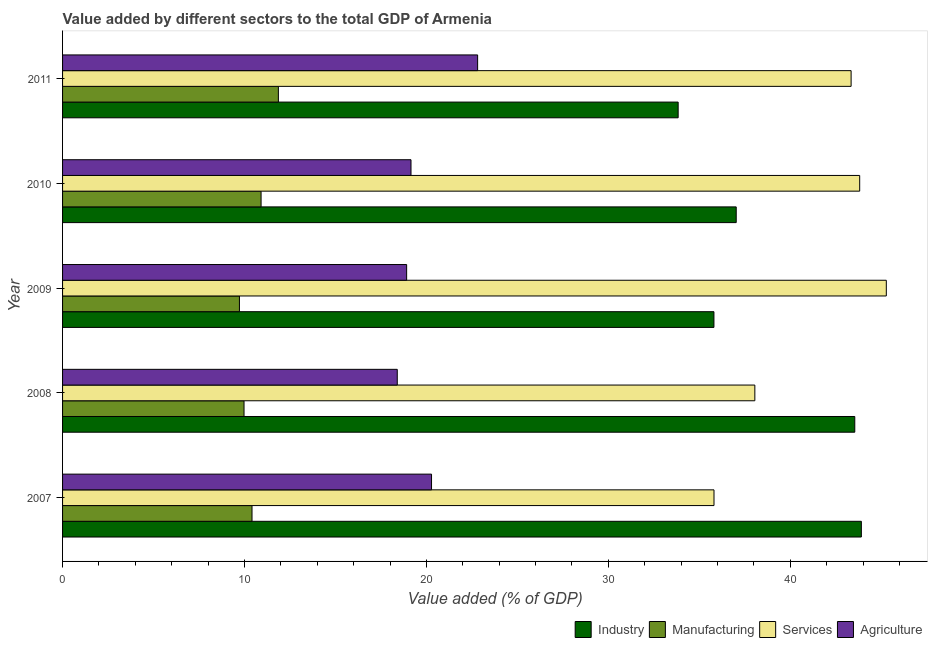How many different coloured bars are there?
Provide a succinct answer. 4. How many groups of bars are there?
Your response must be concise. 5. Are the number of bars per tick equal to the number of legend labels?
Your answer should be compact. Yes. What is the label of the 3rd group of bars from the top?
Your response must be concise. 2009. In how many cases, is the number of bars for a given year not equal to the number of legend labels?
Your answer should be very brief. 0. What is the value added by services sector in 2008?
Provide a succinct answer. 38.05. Across all years, what is the maximum value added by agricultural sector?
Ensure brevity in your answer.  22.82. Across all years, what is the minimum value added by agricultural sector?
Your answer should be compact. 18.4. In which year was the value added by manufacturing sector maximum?
Provide a succinct answer. 2011. In which year was the value added by industrial sector minimum?
Keep it short and to the point. 2011. What is the total value added by services sector in the graph?
Your response must be concise. 206.31. What is the difference between the value added by services sector in 2008 and that in 2010?
Keep it short and to the point. -5.76. What is the difference between the value added by agricultural sector in 2010 and the value added by services sector in 2008?
Your answer should be very brief. -18.9. What is the average value added by manufacturing sector per year?
Provide a short and direct response. 10.58. In the year 2011, what is the difference between the value added by agricultural sector and value added by industrial sector?
Your response must be concise. -11.02. In how many years, is the value added by agricultural sector greater than 42 %?
Offer a very short reply. 0. What is the ratio of the value added by agricultural sector in 2008 to that in 2011?
Give a very brief answer. 0.81. What is the difference between the highest and the lowest value added by services sector?
Offer a terse response. 9.47. In how many years, is the value added by manufacturing sector greater than the average value added by manufacturing sector taken over all years?
Keep it short and to the point. 2. Is the sum of the value added by services sector in 2010 and 2011 greater than the maximum value added by industrial sector across all years?
Keep it short and to the point. Yes. Is it the case that in every year, the sum of the value added by industrial sector and value added by manufacturing sector is greater than the sum of value added by services sector and value added by agricultural sector?
Your answer should be compact. No. What does the 2nd bar from the top in 2010 represents?
Ensure brevity in your answer.  Services. What does the 1st bar from the bottom in 2008 represents?
Your answer should be very brief. Industry. How many bars are there?
Your answer should be compact. 20. Are all the bars in the graph horizontal?
Your response must be concise. Yes. How many years are there in the graph?
Offer a terse response. 5. Are the values on the major ticks of X-axis written in scientific E-notation?
Provide a succinct answer. No. Does the graph contain any zero values?
Offer a terse response. No. What is the title of the graph?
Ensure brevity in your answer.  Value added by different sectors to the total GDP of Armenia. Does "Austria" appear as one of the legend labels in the graph?
Give a very brief answer. No. What is the label or title of the X-axis?
Give a very brief answer. Value added (% of GDP). What is the label or title of the Y-axis?
Your answer should be compact. Year. What is the Value added (% of GDP) of Industry in 2007?
Ensure brevity in your answer.  43.91. What is the Value added (% of GDP) of Manufacturing in 2007?
Your answer should be very brief. 10.41. What is the Value added (% of GDP) of Services in 2007?
Ensure brevity in your answer.  35.81. What is the Value added (% of GDP) in Agriculture in 2007?
Keep it short and to the point. 20.28. What is the Value added (% of GDP) in Industry in 2008?
Your answer should be very brief. 43.55. What is the Value added (% of GDP) of Manufacturing in 2008?
Ensure brevity in your answer.  9.98. What is the Value added (% of GDP) of Services in 2008?
Ensure brevity in your answer.  38.05. What is the Value added (% of GDP) in Agriculture in 2008?
Ensure brevity in your answer.  18.4. What is the Value added (% of GDP) of Industry in 2009?
Provide a short and direct response. 35.81. What is the Value added (% of GDP) of Manufacturing in 2009?
Your answer should be compact. 9.72. What is the Value added (% of GDP) in Services in 2009?
Provide a succinct answer. 45.28. What is the Value added (% of GDP) of Agriculture in 2009?
Your answer should be compact. 18.91. What is the Value added (% of GDP) of Industry in 2010?
Your answer should be very brief. 37.03. What is the Value added (% of GDP) in Manufacturing in 2010?
Your answer should be compact. 10.91. What is the Value added (% of GDP) of Services in 2010?
Offer a terse response. 43.82. What is the Value added (% of GDP) of Agriculture in 2010?
Give a very brief answer. 19.15. What is the Value added (% of GDP) in Industry in 2011?
Provide a short and direct response. 33.84. What is the Value added (% of GDP) of Manufacturing in 2011?
Offer a terse response. 11.86. What is the Value added (% of GDP) of Services in 2011?
Your answer should be very brief. 43.35. What is the Value added (% of GDP) in Agriculture in 2011?
Provide a short and direct response. 22.82. Across all years, what is the maximum Value added (% of GDP) in Industry?
Your answer should be compact. 43.91. Across all years, what is the maximum Value added (% of GDP) in Manufacturing?
Ensure brevity in your answer.  11.86. Across all years, what is the maximum Value added (% of GDP) of Services?
Your response must be concise. 45.28. Across all years, what is the maximum Value added (% of GDP) in Agriculture?
Your response must be concise. 22.82. Across all years, what is the minimum Value added (% of GDP) in Industry?
Make the answer very short. 33.84. Across all years, what is the minimum Value added (% of GDP) of Manufacturing?
Offer a terse response. 9.72. Across all years, what is the minimum Value added (% of GDP) of Services?
Your answer should be compact. 35.81. Across all years, what is the minimum Value added (% of GDP) in Agriculture?
Your answer should be compact. 18.4. What is the total Value added (% of GDP) of Industry in the graph?
Provide a succinct answer. 194.13. What is the total Value added (% of GDP) in Manufacturing in the graph?
Provide a short and direct response. 52.89. What is the total Value added (% of GDP) in Services in the graph?
Your answer should be very brief. 206.31. What is the total Value added (% of GDP) of Agriculture in the graph?
Your answer should be compact. 99.56. What is the difference between the Value added (% of GDP) in Industry in 2007 and that in 2008?
Your answer should be very brief. 0.36. What is the difference between the Value added (% of GDP) in Manufacturing in 2007 and that in 2008?
Give a very brief answer. 0.44. What is the difference between the Value added (% of GDP) in Services in 2007 and that in 2008?
Give a very brief answer. -2.25. What is the difference between the Value added (% of GDP) of Agriculture in 2007 and that in 2008?
Keep it short and to the point. 1.88. What is the difference between the Value added (% of GDP) of Industry in 2007 and that in 2009?
Offer a terse response. 8.1. What is the difference between the Value added (% of GDP) in Manufacturing in 2007 and that in 2009?
Make the answer very short. 0.69. What is the difference between the Value added (% of GDP) in Services in 2007 and that in 2009?
Your answer should be compact. -9.47. What is the difference between the Value added (% of GDP) of Agriculture in 2007 and that in 2009?
Keep it short and to the point. 1.37. What is the difference between the Value added (% of GDP) in Industry in 2007 and that in 2010?
Provide a succinct answer. 6.88. What is the difference between the Value added (% of GDP) of Manufacturing in 2007 and that in 2010?
Offer a very short reply. -0.5. What is the difference between the Value added (% of GDP) of Services in 2007 and that in 2010?
Give a very brief answer. -8.01. What is the difference between the Value added (% of GDP) of Agriculture in 2007 and that in 2010?
Make the answer very short. 1.13. What is the difference between the Value added (% of GDP) of Industry in 2007 and that in 2011?
Give a very brief answer. 10.07. What is the difference between the Value added (% of GDP) in Manufacturing in 2007 and that in 2011?
Ensure brevity in your answer.  -1.45. What is the difference between the Value added (% of GDP) of Services in 2007 and that in 2011?
Keep it short and to the point. -7.54. What is the difference between the Value added (% of GDP) in Agriculture in 2007 and that in 2011?
Keep it short and to the point. -2.53. What is the difference between the Value added (% of GDP) of Industry in 2008 and that in 2009?
Provide a succinct answer. 7.74. What is the difference between the Value added (% of GDP) in Manufacturing in 2008 and that in 2009?
Your response must be concise. 0.25. What is the difference between the Value added (% of GDP) of Services in 2008 and that in 2009?
Your answer should be very brief. -7.23. What is the difference between the Value added (% of GDP) of Agriculture in 2008 and that in 2009?
Keep it short and to the point. -0.52. What is the difference between the Value added (% of GDP) of Industry in 2008 and that in 2010?
Offer a very short reply. 6.52. What is the difference between the Value added (% of GDP) of Manufacturing in 2008 and that in 2010?
Ensure brevity in your answer.  -0.94. What is the difference between the Value added (% of GDP) in Services in 2008 and that in 2010?
Give a very brief answer. -5.76. What is the difference between the Value added (% of GDP) in Agriculture in 2008 and that in 2010?
Offer a very short reply. -0.75. What is the difference between the Value added (% of GDP) in Industry in 2008 and that in 2011?
Keep it short and to the point. 9.71. What is the difference between the Value added (% of GDP) of Manufacturing in 2008 and that in 2011?
Give a very brief answer. -1.89. What is the difference between the Value added (% of GDP) of Services in 2008 and that in 2011?
Provide a succinct answer. -5.29. What is the difference between the Value added (% of GDP) in Agriculture in 2008 and that in 2011?
Offer a very short reply. -4.42. What is the difference between the Value added (% of GDP) in Industry in 2009 and that in 2010?
Give a very brief answer. -1.22. What is the difference between the Value added (% of GDP) of Manufacturing in 2009 and that in 2010?
Your response must be concise. -1.19. What is the difference between the Value added (% of GDP) of Services in 2009 and that in 2010?
Your response must be concise. 1.46. What is the difference between the Value added (% of GDP) in Agriculture in 2009 and that in 2010?
Keep it short and to the point. -0.24. What is the difference between the Value added (% of GDP) of Industry in 2009 and that in 2011?
Make the answer very short. 1.97. What is the difference between the Value added (% of GDP) in Manufacturing in 2009 and that in 2011?
Your response must be concise. -2.14. What is the difference between the Value added (% of GDP) in Services in 2009 and that in 2011?
Provide a succinct answer. 1.93. What is the difference between the Value added (% of GDP) in Agriculture in 2009 and that in 2011?
Ensure brevity in your answer.  -3.9. What is the difference between the Value added (% of GDP) of Industry in 2010 and that in 2011?
Your answer should be compact. 3.19. What is the difference between the Value added (% of GDP) in Manufacturing in 2010 and that in 2011?
Keep it short and to the point. -0.95. What is the difference between the Value added (% of GDP) of Services in 2010 and that in 2011?
Ensure brevity in your answer.  0.47. What is the difference between the Value added (% of GDP) in Agriculture in 2010 and that in 2011?
Give a very brief answer. -3.66. What is the difference between the Value added (% of GDP) in Industry in 2007 and the Value added (% of GDP) in Manufacturing in 2008?
Keep it short and to the point. 33.93. What is the difference between the Value added (% of GDP) in Industry in 2007 and the Value added (% of GDP) in Services in 2008?
Give a very brief answer. 5.85. What is the difference between the Value added (% of GDP) of Industry in 2007 and the Value added (% of GDP) of Agriculture in 2008?
Provide a succinct answer. 25.51. What is the difference between the Value added (% of GDP) in Manufacturing in 2007 and the Value added (% of GDP) in Services in 2008?
Make the answer very short. -27.64. What is the difference between the Value added (% of GDP) of Manufacturing in 2007 and the Value added (% of GDP) of Agriculture in 2008?
Your answer should be compact. -7.98. What is the difference between the Value added (% of GDP) in Services in 2007 and the Value added (% of GDP) in Agriculture in 2008?
Your answer should be very brief. 17.41. What is the difference between the Value added (% of GDP) of Industry in 2007 and the Value added (% of GDP) of Manufacturing in 2009?
Offer a terse response. 34.19. What is the difference between the Value added (% of GDP) of Industry in 2007 and the Value added (% of GDP) of Services in 2009?
Give a very brief answer. -1.37. What is the difference between the Value added (% of GDP) of Industry in 2007 and the Value added (% of GDP) of Agriculture in 2009?
Your response must be concise. 24.99. What is the difference between the Value added (% of GDP) in Manufacturing in 2007 and the Value added (% of GDP) in Services in 2009?
Your answer should be very brief. -34.87. What is the difference between the Value added (% of GDP) of Manufacturing in 2007 and the Value added (% of GDP) of Agriculture in 2009?
Offer a terse response. -8.5. What is the difference between the Value added (% of GDP) of Services in 2007 and the Value added (% of GDP) of Agriculture in 2009?
Give a very brief answer. 16.9. What is the difference between the Value added (% of GDP) of Industry in 2007 and the Value added (% of GDP) of Manufacturing in 2010?
Provide a short and direct response. 33. What is the difference between the Value added (% of GDP) in Industry in 2007 and the Value added (% of GDP) in Services in 2010?
Provide a succinct answer. 0.09. What is the difference between the Value added (% of GDP) in Industry in 2007 and the Value added (% of GDP) in Agriculture in 2010?
Your answer should be compact. 24.76. What is the difference between the Value added (% of GDP) in Manufacturing in 2007 and the Value added (% of GDP) in Services in 2010?
Provide a succinct answer. -33.4. What is the difference between the Value added (% of GDP) in Manufacturing in 2007 and the Value added (% of GDP) in Agriculture in 2010?
Your answer should be compact. -8.74. What is the difference between the Value added (% of GDP) in Services in 2007 and the Value added (% of GDP) in Agriculture in 2010?
Offer a very short reply. 16.66. What is the difference between the Value added (% of GDP) in Industry in 2007 and the Value added (% of GDP) in Manufacturing in 2011?
Provide a short and direct response. 32.05. What is the difference between the Value added (% of GDP) of Industry in 2007 and the Value added (% of GDP) of Services in 2011?
Offer a terse response. 0.56. What is the difference between the Value added (% of GDP) of Industry in 2007 and the Value added (% of GDP) of Agriculture in 2011?
Your response must be concise. 21.09. What is the difference between the Value added (% of GDP) of Manufacturing in 2007 and the Value added (% of GDP) of Services in 2011?
Your response must be concise. -32.93. What is the difference between the Value added (% of GDP) in Manufacturing in 2007 and the Value added (% of GDP) in Agriculture in 2011?
Make the answer very short. -12.4. What is the difference between the Value added (% of GDP) in Services in 2007 and the Value added (% of GDP) in Agriculture in 2011?
Make the answer very short. 12.99. What is the difference between the Value added (% of GDP) in Industry in 2008 and the Value added (% of GDP) in Manufacturing in 2009?
Your answer should be compact. 33.83. What is the difference between the Value added (% of GDP) of Industry in 2008 and the Value added (% of GDP) of Services in 2009?
Make the answer very short. -1.73. What is the difference between the Value added (% of GDP) of Industry in 2008 and the Value added (% of GDP) of Agriculture in 2009?
Make the answer very short. 24.63. What is the difference between the Value added (% of GDP) in Manufacturing in 2008 and the Value added (% of GDP) in Services in 2009?
Your answer should be very brief. -35.31. What is the difference between the Value added (% of GDP) of Manufacturing in 2008 and the Value added (% of GDP) of Agriculture in 2009?
Ensure brevity in your answer.  -8.94. What is the difference between the Value added (% of GDP) in Services in 2008 and the Value added (% of GDP) in Agriculture in 2009?
Make the answer very short. 19.14. What is the difference between the Value added (% of GDP) of Industry in 2008 and the Value added (% of GDP) of Manufacturing in 2010?
Give a very brief answer. 32.64. What is the difference between the Value added (% of GDP) of Industry in 2008 and the Value added (% of GDP) of Services in 2010?
Offer a very short reply. -0.27. What is the difference between the Value added (% of GDP) of Industry in 2008 and the Value added (% of GDP) of Agriculture in 2010?
Give a very brief answer. 24.39. What is the difference between the Value added (% of GDP) of Manufacturing in 2008 and the Value added (% of GDP) of Services in 2010?
Your answer should be very brief. -33.84. What is the difference between the Value added (% of GDP) of Manufacturing in 2008 and the Value added (% of GDP) of Agriculture in 2010?
Ensure brevity in your answer.  -9.18. What is the difference between the Value added (% of GDP) in Services in 2008 and the Value added (% of GDP) in Agriculture in 2010?
Provide a short and direct response. 18.9. What is the difference between the Value added (% of GDP) of Industry in 2008 and the Value added (% of GDP) of Manufacturing in 2011?
Offer a very short reply. 31.68. What is the difference between the Value added (% of GDP) in Industry in 2008 and the Value added (% of GDP) in Services in 2011?
Ensure brevity in your answer.  0.2. What is the difference between the Value added (% of GDP) of Industry in 2008 and the Value added (% of GDP) of Agriculture in 2011?
Provide a succinct answer. 20.73. What is the difference between the Value added (% of GDP) of Manufacturing in 2008 and the Value added (% of GDP) of Services in 2011?
Give a very brief answer. -33.37. What is the difference between the Value added (% of GDP) of Manufacturing in 2008 and the Value added (% of GDP) of Agriculture in 2011?
Offer a terse response. -12.84. What is the difference between the Value added (% of GDP) of Services in 2008 and the Value added (% of GDP) of Agriculture in 2011?
Make the answer very short. 15.24. What is the difference between the Value added (% of GDP) in Industry in 2009 and the Value added (% of GDP) in Manufacturing in 2010?
Your answer should be compact. 24.89. What is the difference between the Value added (% of GDP) of Industry in 2009 and the Value added (% of GDP) of Services in 2010?
Your response must be concise. -8.01. What is the difference between the Value added (% of GDP) in Industry in 2009 and the Value added (% of GDP) in Agriculture in 2010?
Your answer should be compact. 16.65. What is the difference between the Value added (% of GDP) of Manufacturing in 2009 and the Value added (% of GDP) of Services in 2010?
Offer a very short reply. -34.09. What is the difference between the Value added (% of GDP) in Manufacturing in 2009 and the Value added (% of GDP) in Agriculture in 2010?
Make the answer very short. -9.43. What is the difference between the Value added (% of GDP) in Services in 2009 and the Value added (% of GDP) in Agriculture in 2010?
Offer a very short reply. 26.13. What is the difference between the Value added (% of GDP) in Industry in 2009 and the Value added (% of GDP) in Manufacturing in 2011?
Ensure brevity in your answer.  23.94. What is the difference between the Value added (% of GDP) of Industry in 2009 and the Value added (% of GDP) of Services in 2011?
Provide a succinct answer. -7.54. What is the difference between the Value added (% of GDP) of Industry in 2009 and the Value added (% of GDP) of Agriculture in 2011?
Offer a very short reply. 12.99. What is the difference between the Value added (% of GDP) in Manufacturing in 2009 and the Value added (% of GDP) in Services in 2011?
Your answer should be very brief. -33.62. What is the difference between the Value added (% of GDP) in Manufacturing in 2009 and the Value added (% of GDP) in Agriculture in 2011?
Keep it short and to the point. -13.09. What is the difference between the Value added (% of GDP) in Services in 2009 and the Value added (% of GDP) in Agriculture in 2011?
Provide a succinct answer. 22.46. What is the difference between the Value added (% of GDP) of Industry in 2010 and the Value added (% of GDP) of Manufacturing in 2011?
Offer a terse response. 25.17. What is the difference between the Value added (% of GDP) of Industry in 2010 and the Value added (% of GDP) of Services in 2011?
Your answer should be compact. -6.32. What is the difference between the Value added (% of GDP) in Industry in 2010 and the Value added (% of GDP) in Agriculture in 2011?
Make the answer very short. 14.21. What is the difference between the Value added (% of GDP) of Manufacturing in 2010 and the Value added (% of GDP) of Services in 2011?
Ensure brevity in your answer.  -32.43. What is the difference between the Value added (% of GDP) of Manufacturing in 2010 and the Value added (% of GDP) of Agriculture in 2011?
Give a very brief answer. -11.9. What is the difference between the Value added (% of GDP) in Services in 2010 and the Value added (% of GDP) in Agriculture in 2011?
Your response must be concise. 21. What is the average Value added (% of GDP) in Industry per year?
Your answer should be compact. 38.83. What is the average Value added (% of GDP) of Manufacturing per year?
Keep it short and to the point. 10.58. What is the average Value added (% of GDP) of Services per year?
Your response must be concise. 41.26. What is the average Value added (% of GDP) in Agriculture per year?
Offer a terse response. 19.91. In the year 2007, what is the difference between the Value added (% of GDP) in Industry and Value added (% of GDP) in Manufacturing?
Keep it short and to the point. 33.49. In the year 2007, what is the difference between the Value added (% of GDP) of Industry and Value added (% of GDP) of Services?
Your response must be concise. 8.1. In the year 2007, what is the difference between the Value added (% of GDP) of Industry and Value added (% of GDP) of Agriculture?
Your response must be concise. 23.63. In the year 2007, what is the difference between the Value added (% of GDP) of Manufacturing and Value added (% of GDP) of Services?
Offer a terse response. -25.4. In the year 2007, what is the difference between the Value added (% of GDP) of Manufacturing and Value added (% of GDP) of Agriculture?
Provide a succinct answer. -9.87. In the year 2007, what is the difference between the Value added (% of GDP) in Services and Value added (% of GDP) in Agriculture?
Your response must be concise. 15.53. In the year 2008, what is the difference between the Value added (% of GDP) of Industry and Value added (% of GDP) of Manufacturing?
Your answer should be compact. 33.57. In the year 2008, what is the difference between the Value added (% of GDP) in Industry and Value added (% of GDP) in Services?
Make the answer very short. 5.49. In the year 2008, what is the difference between the Value added (% of GDP) of Industry and Value added (% of GDP) of Agriculture?
Give a very brief answer. 25.15. In the year 2008, what is the difference between the Value added (% of GDP) in Manufacturing and Value added (% of GDP) in Services?
Offer a terse response. -28.08. In the year 2008, what is the difference between the Value added (% of GDP) in Manufacturing and Value added (% of GDP) in Agriculture?
Make the answer very short. -8.42. In the year 2008, what is the difference between the Value added (% of GDP) in Services and Value added (% of GDP) in Agriculture?
Keep it short and to the point. 19.66. In the year 2009, what is the difference between the Value added (% of GDP) of Industry and Value added (% of GDP) of Manufacturing?
Your answer should be very brief. 26.08. In the year 2009, what is the difference between the Value added (% of GDP) in Industry and Value added (% of GDP) in Services?
Provide a succinct answer. -9.47. In the year 2009, what is the difference between the Value added (% of GDP) of Industry and Value added (% of GDP) of Agriculture?
Your answer should be compact. 16.89. In the year 2009, what is the difference between the Value added (% of GDP) in Manufacturing and Value added (% of GDP) in Services?
Offer a terse response. -35.56. In the year 2009, what is the difference between the Value added (% of GDP) in Manufacturing and Value added (% of GDP) in Agriculture?
Give a very brief answer. -9.19. In the year 2009, what is the difference between the Value added (% of GDP) of Services and Value added (% of GDP) of Agriculture?
Your answer should be very brief. 26.37. In the year 2010, what is the difference between the Value added (% of GDP) of Industry and Value added (% of GDP) of Manufacturing?
Offer a very short reply. 26.12. In the year 2010, what is the difference between the Value added (% of GDP) in Industry and Value added (% of GDP) in Services?
Your response must be concise. -6.79. In the year 2010, what is the difference between the Value added (% of GDP) of Industry and Value added (% of GDP) of Agriculture?
Your response must be concise. 17.88. In the year 2010, what is the difference between the Value added (% of GDP) of Manufacturing and Value added (% of GDP) of Services?
Offer a very short reply. -32.91. In the year 2010, what is the difference between the Value added (% of GDP) of Manufacturing and Value added (% of GDP) of Agriculture?
Keep it short and to the point. -8.24. In the year 2010, what is the difference between the Value added (% of GDP) of Services and Value added (% of GDP) of Agriculture?
Give a very brief answer. 24.66. In the year 2011, what is the difference between the Value added (% of GDP) of Industry and Value added (% of GDP) of Manufacturing?
Give a very brief answer. 21.98. In the year 2011, what is the difference between the Value added (% of GDP) of Industry and Value added (% of GDP) of Services?
Offer a terse response. -9.51. In the year 2011, what is the difference between the Value added (% of GDP) of Industry and Value added (% of GDP) of Agriculture?
Your answer should be compact. 11.02. In the year 2011, what is the difference between the Value added (% of GDP) in Manufacturing and Value added (% of GDP) in Services?
Ensure brevity in your answer.  -31.48. In the year 2011, what is the difference between the Value added (% of GDP) in Manufacturing and Value added (% of GDP) in Agriculture?
Keep it short and to the point. -10.95. In the year 2011, what is the difference between the Value added (% of GDP) in Services and Value added (% of GDP) in Agriculture?
Your response must be concise. 20.53. What is the ratio of the Value added (% of GDP) of Industry in 2007 to that in 2008?
Give a very brief answer. 1.01. What is the ratio of the Value added (% of GDP) of Manufacturing in 2007 to that in 2008?
Provide a succinct answer. 1.04. What is the ratio of the Value added (% of GDP) of Services in 2007 to that in 2008?
Your answer should be very brief. 0.94. What is the ratio of the Value added (% of GDP) of Agriculture in 2007 to that in 2008?
Your answer should be very brief. 1.1. What is the ratio of the Value added (% of GDP) in Industry in 2007 to that in 2009?
Ensure brevity in your answer.  1.23. What is the ratio of the Value added (% of GDP) in Manufacturing in 2007 to that in 2009?
Ensure brevity in your answer.  1.07. What is the ratio of the Value added (% of GDP) in Services in 2007 to that in 2009?
Your response must be concise. 0.79. What is the ratio of the Value added (% of GDP) of Agriculture in 2007 to that in 2009?
Give a very brief answer. 1.07. What is the ratio of the Value added (% of GDP) in Industry in 2007 to that in 2010?
Provide a succinct answer. 1.19. What is the ratio of the Value added (% of GDP) of Manufacturing in 2007 to that in 2010?
Ensure brevity in your answer.  0.95. What is the ratio of the Value added (% of GDP) of Services in 2007 to that in 2010?
Provide a succinct answer. 0.82. What is the ratio of the Value added (% of GDP) in Agriculture in 2007 to that in 2010?
Your answer should be very brief. 1.06. What is the ratio of the Value added (% of GDP) of Industry in 2007 to that in 2011?
Ensure brevity in your answer.  1.3. What is the ratio of the Value added (% of GDP) of Manufacturing in 2007 to that in 2011?
Give a very brief answer. 0.88. What is the ratio of the Value added (% of GDP) of Services in 2007 to that in 2011?
Ensure brevity in your answer.  0.83. What is the ratio of the Value added (% of GDP) of Agriculture in 2007 to that in 2011?
Your answer should be compact. 0.89. What is the ratio of the Value added (% of GDP) of Industry in 2008 to that in 2009?
Provide a short and direct response. 1.22. What is the ratio of the Value added (% of GDP) in Manufacturing in 2008 to that in 2009?
Ensure brevity in your answer.  1.03. What is the ratio of the Value added (% of GDP) in Services in 2008 to that in 2009?
Provide a succinct answer. 0.84. What is the ratio of the Value added (% of GDP) in Agriculture in 2008 to that in 2009?
Provide a succinct answer. 0.97. What is the ratio of the Value added (% of GDP) in Industry in 2008 to that in 2010?
Provide a short and direct response. 1.18. What is the ratio of the Value added (% of GDP) of Manufacturing in 2008 to that in 2010?
Provide a short and direct response. 0.91. What is the ratio of the Value added (% of GDP) in Services in 2008 to that in 2010?
Offer a terse response. 0.87. What is the ratio of the Value added (% of GDP) of Agriculture in 2008 to that in 2010?
Your response must be concise. 0.96. What is the ratio of the Value added (% of GDP) in Industry in 2008 to that in 2011?
Offer a very short reply. 1.29. What is the ratio of the Value added (% of GDP) in Manufacturing in 2008 to that in 2011?
Your answer should be compact. 0.84. What is the ratio of the Value added (% of GDP) of Services in 2008 to that in 2011?
Your response must be concise. 0.88. What is the ratio of the Value added (% of GDP) in Agriculture in 2008 to that in 2011?
Make the answer very short. 0.81. What is the ratio of the Value added (% of GDP) of Industry in 2009 to that in 2010?
Provide a succinct answer. 0.97. What is the ratio of the Value added (% of GDP) of Manufacturing in 2009 to that in 2010?
Keep it short and to the point. 0.89. What is the ratio of the Value added (% of GDP) in Services in 2009 to that in 2010?
Provide a succinct answer. 1.03. What is the ratio of the Value added (% of GDP) in Agriculture in 2009 to that in 2010?
Make the answer very short. 0.99. What is the ratio of the Value added (% of GDP) in Industry in 2009 to that in 2011?
Give a very brief answer. 1.06. What is the ratio of the Value added (% of GDP) in Manufacturing in 2009 to that in 2011?
Your answer should be compact. 0.82. What is the ratio of the Value added (% of GDP) of Services in 2009 to that in 2011?
Give a very brief answer. 1.04. What is the ratio of the Value added (% of GDP) of Agriculture in 2009 to that in 2011?
Make the answer very short. 0.83. What is the ratio of the Value added (% of GDP) in Industry in 2010 to that in 2011?
Provide a succinct answer. 1.09. What is the ratio of the Value added (% of GDP) in Manufacturing in 2010 to that in 2011?
Keep it short and to the point. 0.92. What is the ratio of the Value added (% of GDP) of Services in 2010 to that in 2011?
Your answer should be very brief. 1.01. What is the ratio of the Value added (% of GDP) in Agriculture in 2010 to that in 2011?
Ensure brevity in your answer.  0.84. What is the difference between the highest and the second highest Value added (% of GDP) in Industry?
Make the answer very short. 0.36. What is the difference between the highest and the second highest Value added (% of GDP) of Manufacturing?
Ensure brevity in your answer.  0.95. What is the difference between the highest and the second highest Value added (% of GDP) of Services?
Your answer should be compact. 1.46. What is the difference between the highest and the second highest Value added (% of GDP) of Agriculture?
Provide a succinct answer. 2.53. What is the difference between the highest and the lowest Value added (% of GDP) in Industry?
Your answer should be compact. 10.07. What is the difference between the highest and the lowest Value added (% of GDP) of Manufacturing?
Your answer should be very brief. 2.14. What is the difference between the highest and the lowest Value added (% of GDP) of Services?
Provide a short and direct response. 9.47. What is the difference between the highest and the lowest Value added (% of GDP) of Agriculture?
Your answer should be very brief. 4.42. 